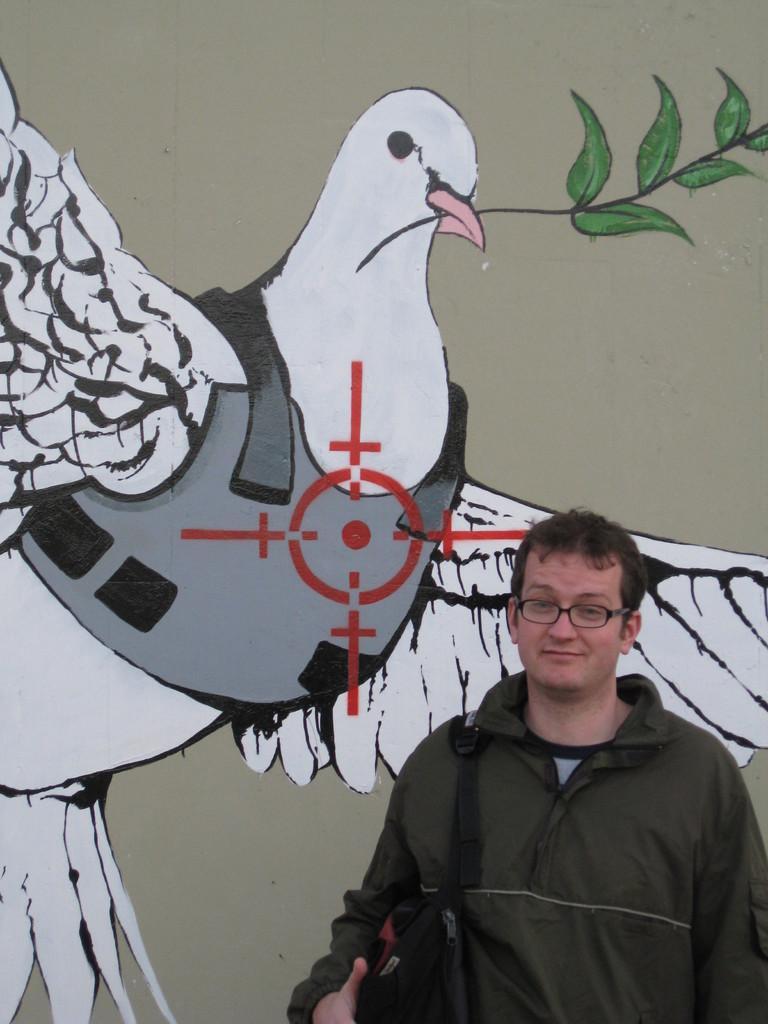Please provide a concise description of this image. In this image we can see a man standing. He is wearing a bag. In the background there is a wall and we can see a painting on the wall. 